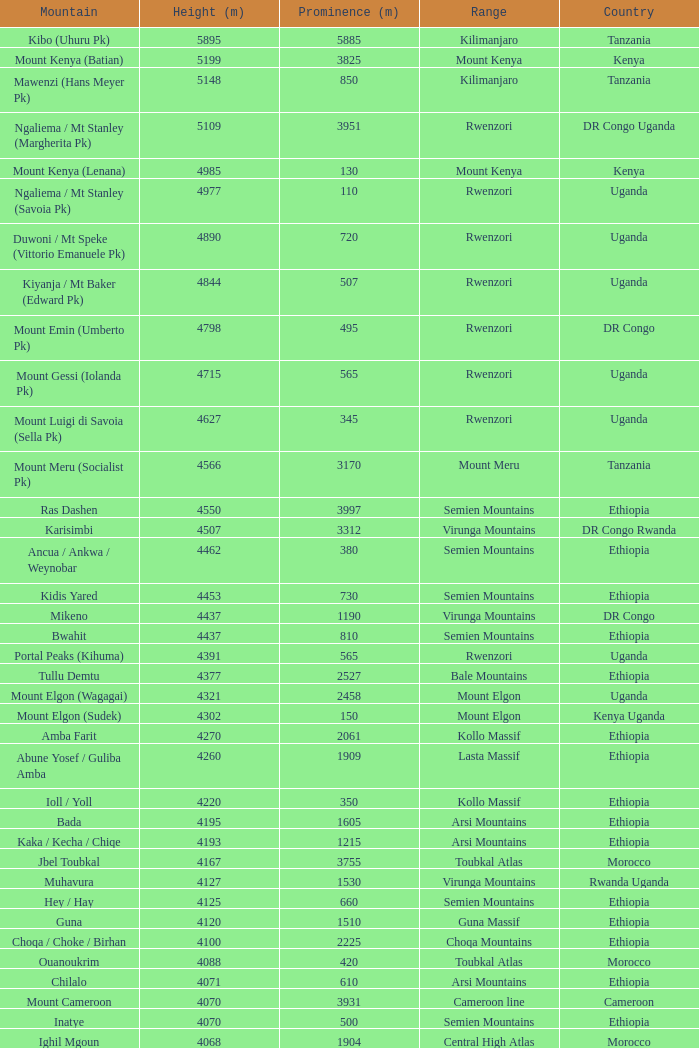Which jurisdiction has a prominence (m) under 1540, and a height (m) under 3530, and a range of virunga DR Congo. 